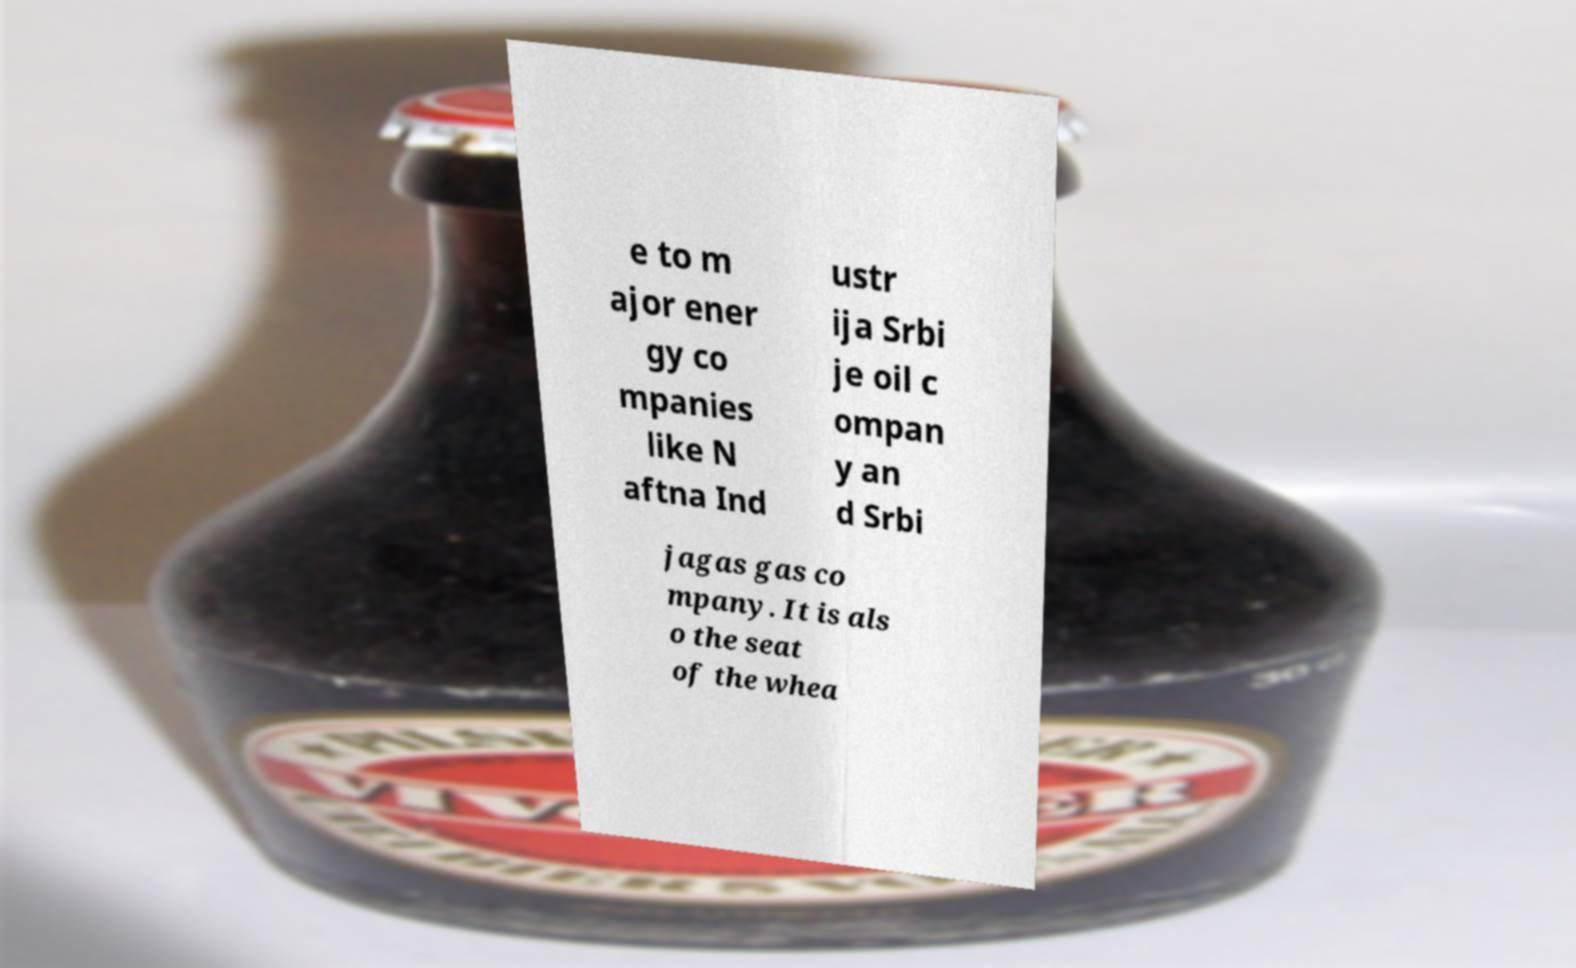Could you extract and type out the text from this image? e to m ajor ener gy co mpanies like N aftna Ind ustr ija Srbi je oil c ompan y an d Srbi jagas gas co mpany. It is als o the seat of the whea 